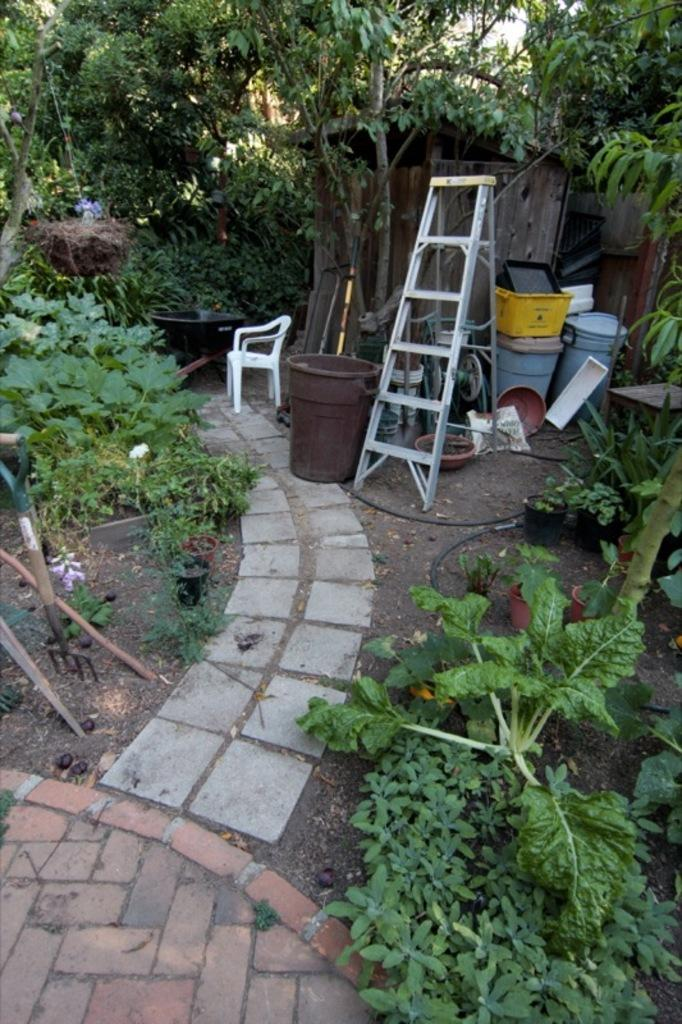What type of furniture is in the image? There is a chair in the image. What is another object that can be seen in the image? There is a ladder in the image. What are the objects on the ground in the image? Dustbins are present on the ground in the image. What type of vegetation is in the image? There are plants and trees in the image. What type of hair can be seen on the chair in the image? There is no hair visible on the chair in the image. What vase is present in the image? There is no vase present in the image. 